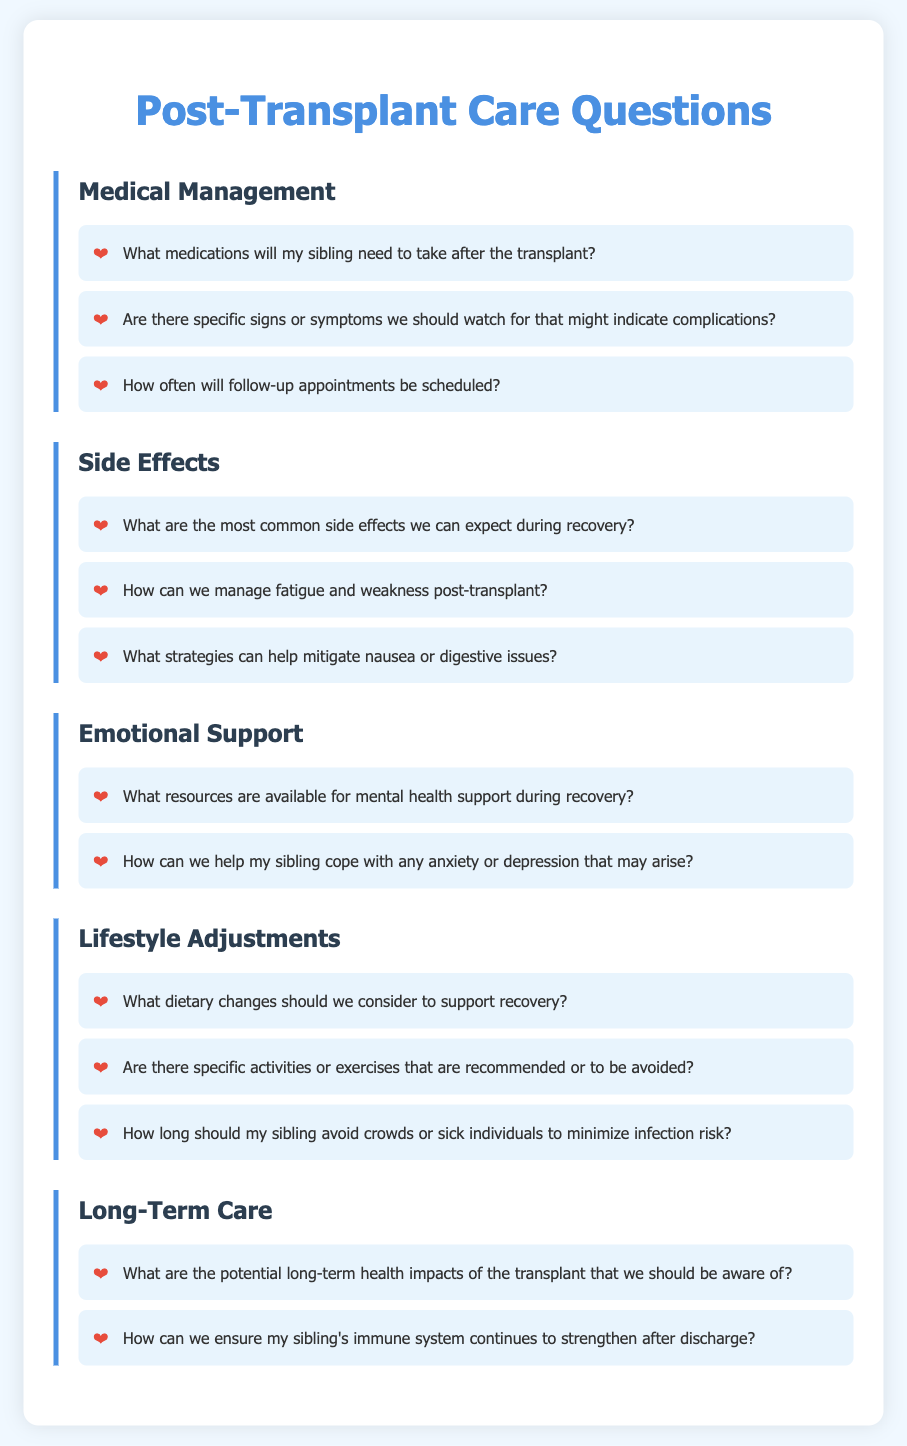What medications will my sibling need to take after the transplant? This question asks for specific information listed under the Medical Management category related to post-transplant care.
Answer: Medications What are the most common side effects we can expect during recovery? This question inquires about side effects mentioned in the Side Effects category of the document.
Answer: Common side effects What resources are available for mental health support during recovery? This question focuses on emotional support resources provided in the Emotional Support category.
Answer: Resources for mental health support What dietary changes should we consider to support recovery? This question seeks information about lifestyle adjustments related to diet from the Lifestyle Adjustments category.
Answer: Dietary changes How long should my sibling avoid crowds or sick individuals to minimize infection risk? This question is specific to lifestyle adjustments that pertain to avoiding crowds as mentioned in the document.
Answer: Duration to avoid crowds How can we ensure my sibling's immune system continues to strengthen after discharge? This question requires reasoning about long-term care strategies for immune support outlined in the Long-Term Care section.
Answer: Immune support strategies 